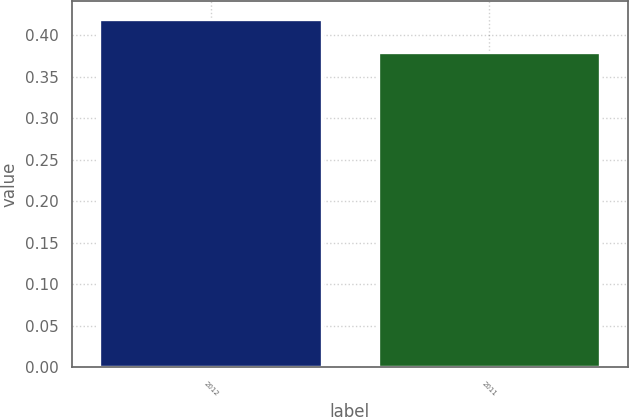Convert chart. <chart><loc_0><loc_0><loc_500><loc_500><bar_chart><fcel>2012<fcel>2011<nl><fcel>0.42<fcel>0.38<nl></chart> 